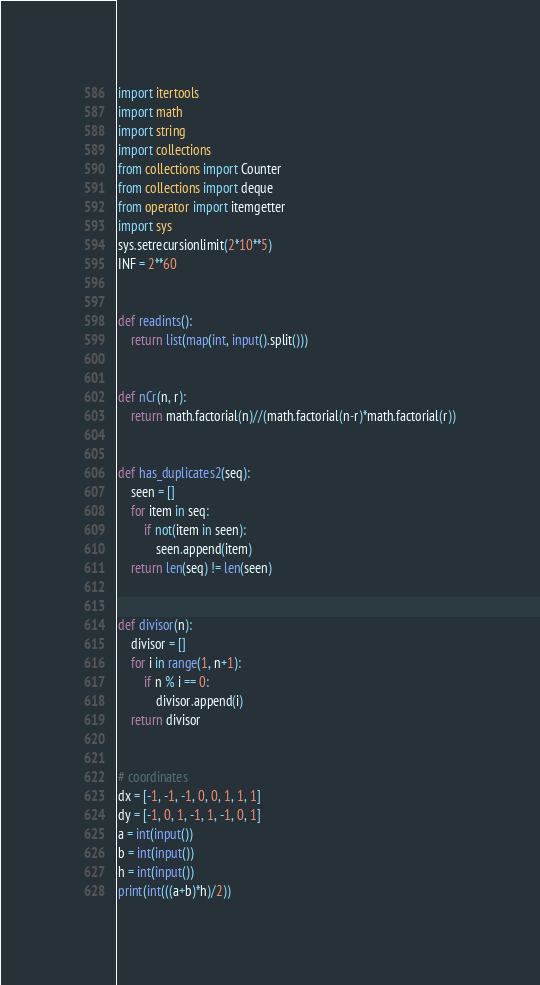Convert code to text. <code><loc_0><loc_0><loc_500><loc_500><_Python_>import itertools
import math
import string
import collections
from collections import Counter
from collections import deque
from operator import itemgetter
import sys
sys.setrecursionlimit(2*10**5)
INF = 2**60


def readints():
    return list(map(int, input().split()))


def nCr(n, r):
    return math.factorial(n)//(math.factorial(n-r)*math.factorial(r))


def has_duplicates2(seq):
    seen = []
    for item in seq:
        if not(item in seen):
            seen.append(item)
    return len(seq) != len(seen)


def divisor(n):
    divisor = []
    for i in range(1, n+1):
        if n % i == 0:
            divisor.append(i)
    return divisor


# coordinates
dx = [-1, -1, -1, 0, 0, 1, 1, 1]
dy = [-1, 0, 1, -1, 1, -1, 0, 1]
a = int(input())
b = int(input())
h = int(input())
print(int(((a+b)*h)/2))
</code> 